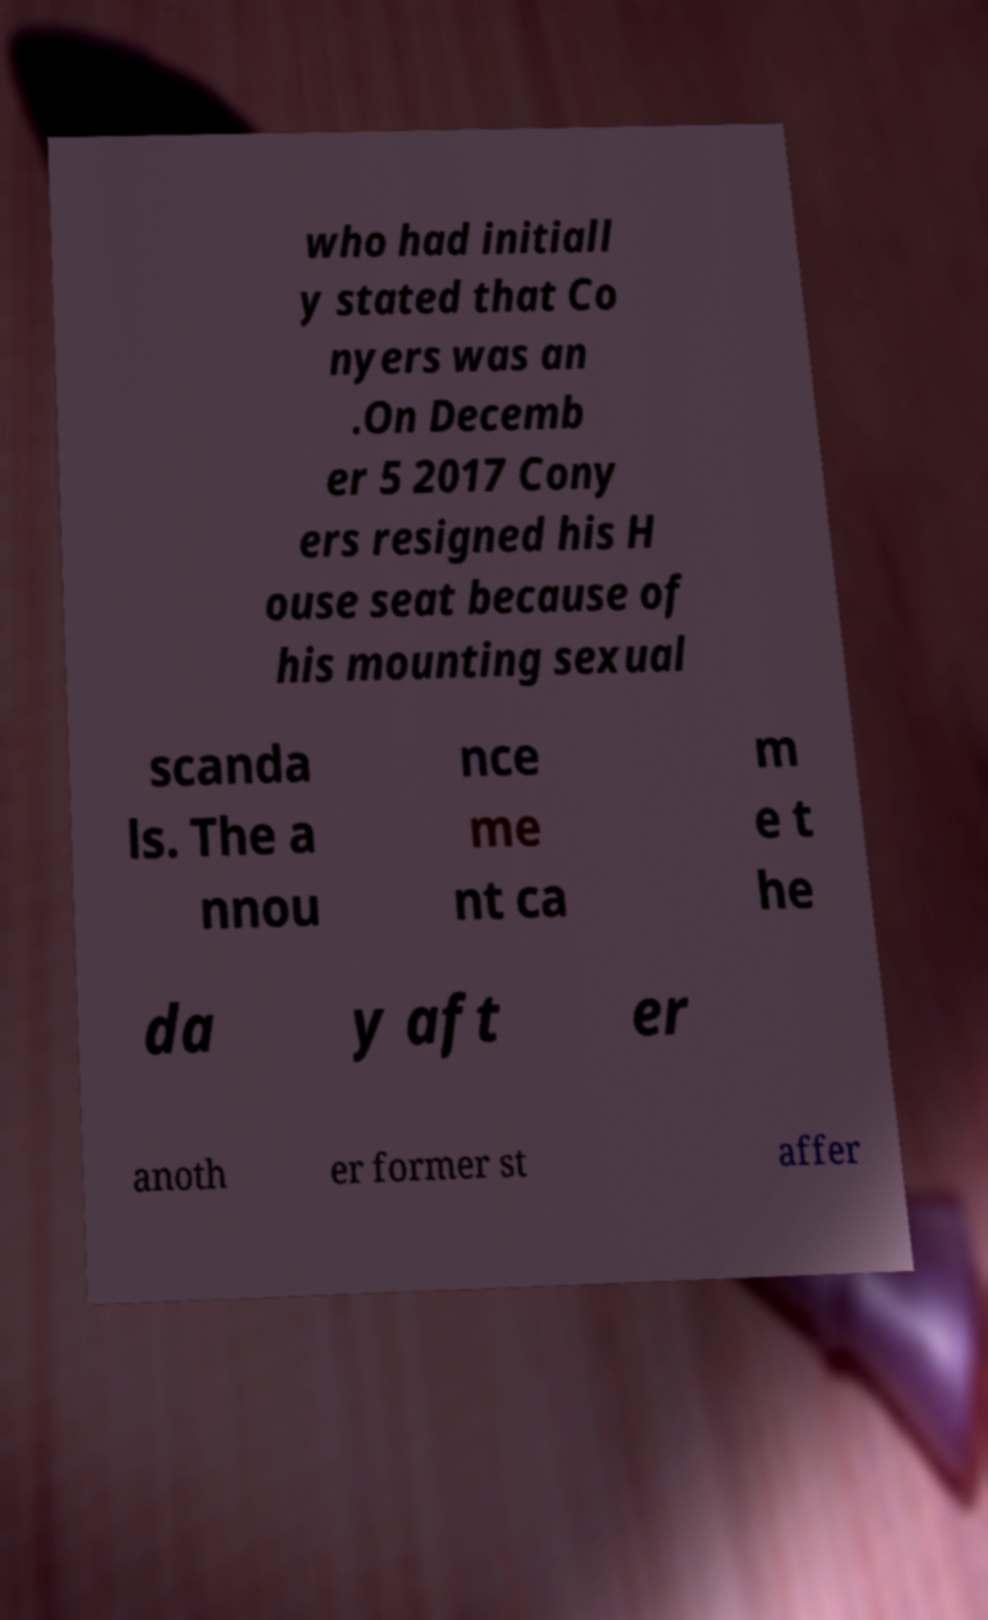Could you extract and type out the text from this image? who had initiall y stated that Co nyers was an .On Decemb er 5 2017 Cony ers resigned his H ouse seat because of his mounting sexual scanda ls. The a nnou nce me nt ca m e t he da y aft er anoth er former st affer 